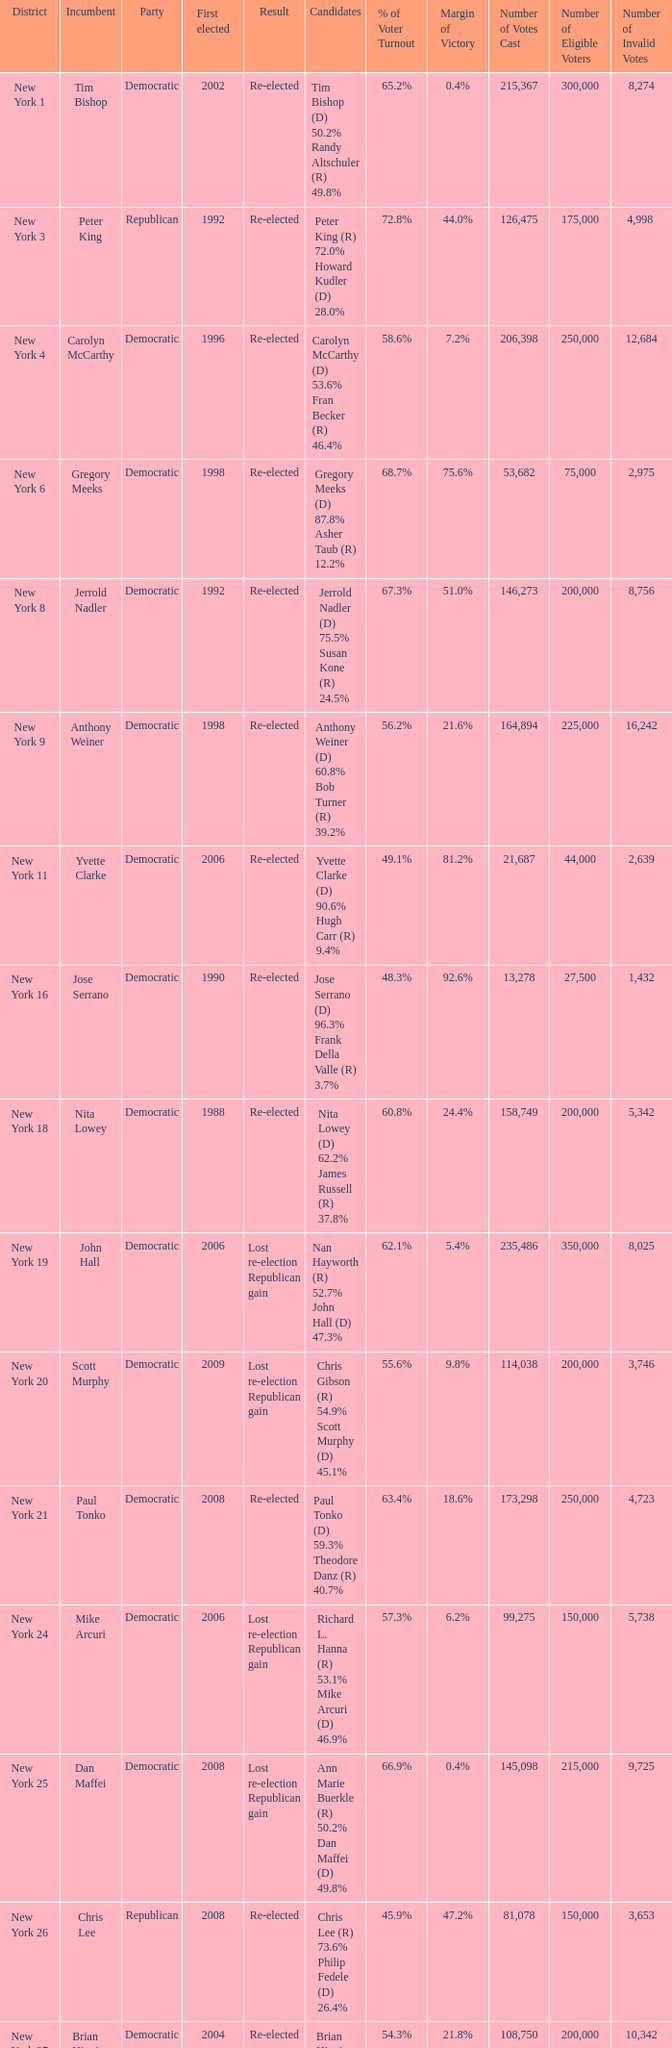Name the party for yvette clarke (d) 90.6% hugh carr (r) 9.4% Democratic. 